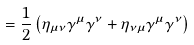<formula> <loc_0><loc_0><loc_500><loc_500>= { \frac { 1 } { 2 } } \left ( \eta _ { \mu \nu } \gamma ^ { \mu } \gamma ^ { \nu } + \eta _ { \nu \mu } \gamma ^ { \mu } \gamma ^ { \nu } \right )</formula> 